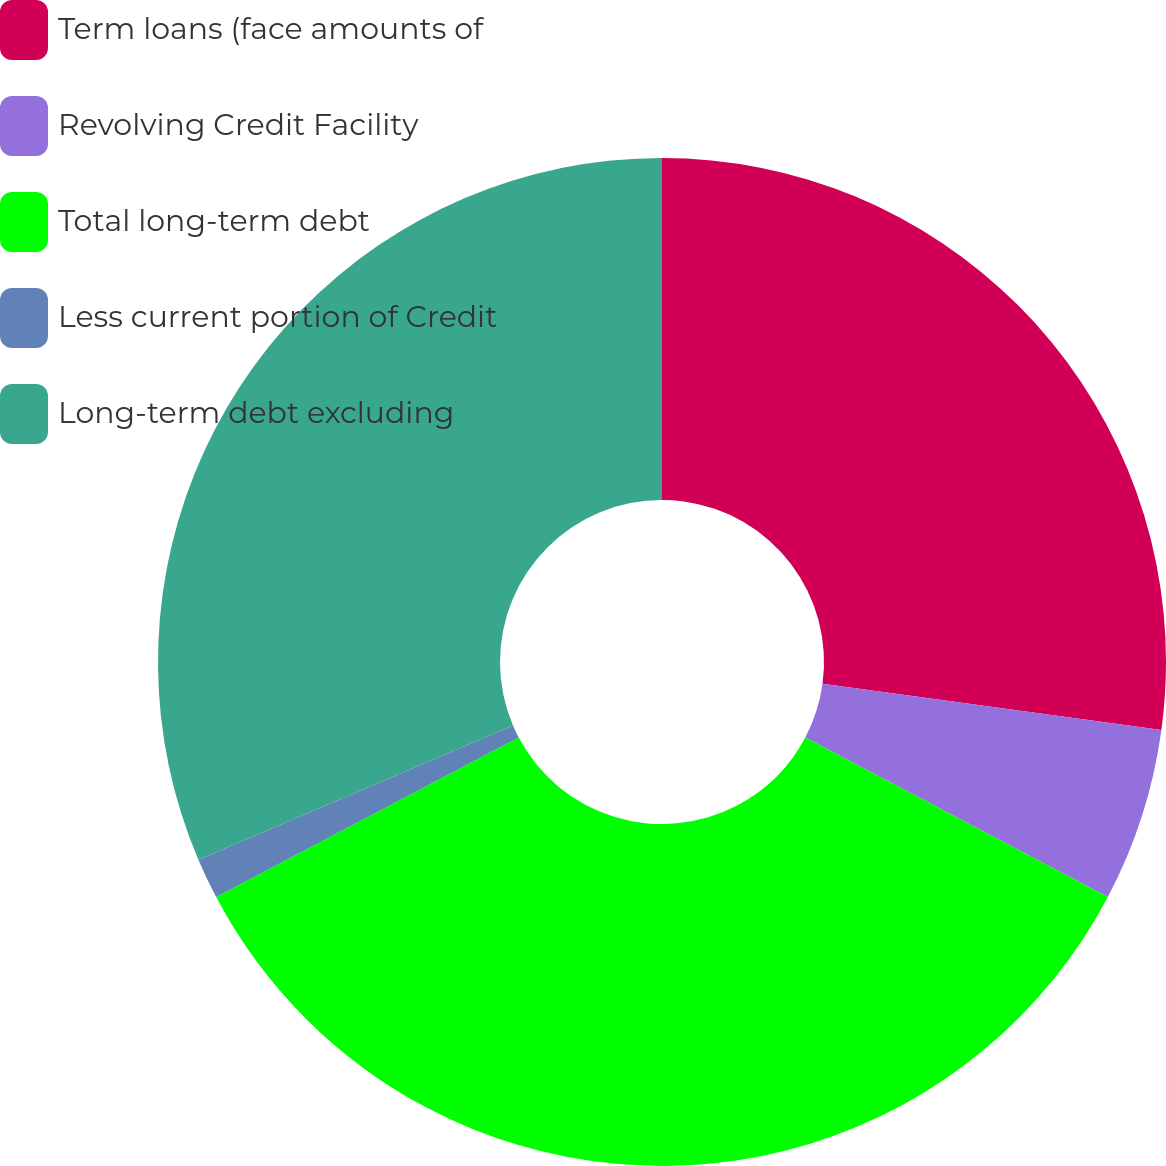<chart> <loc_0><loc_0><loc_500><loc_500><pie_chart><fcel>Term loans (face amounts of<fcel>Revolving Credit Facility<fcel>Total long-term debt<fcel>Less current portion of Credit<fcel>Long-term debt excluding<nl><fcel>27.15%<fcel>5.57%<fcel>34.55%<fcel>1.31%<fcel>31.41%<nl></chart> 